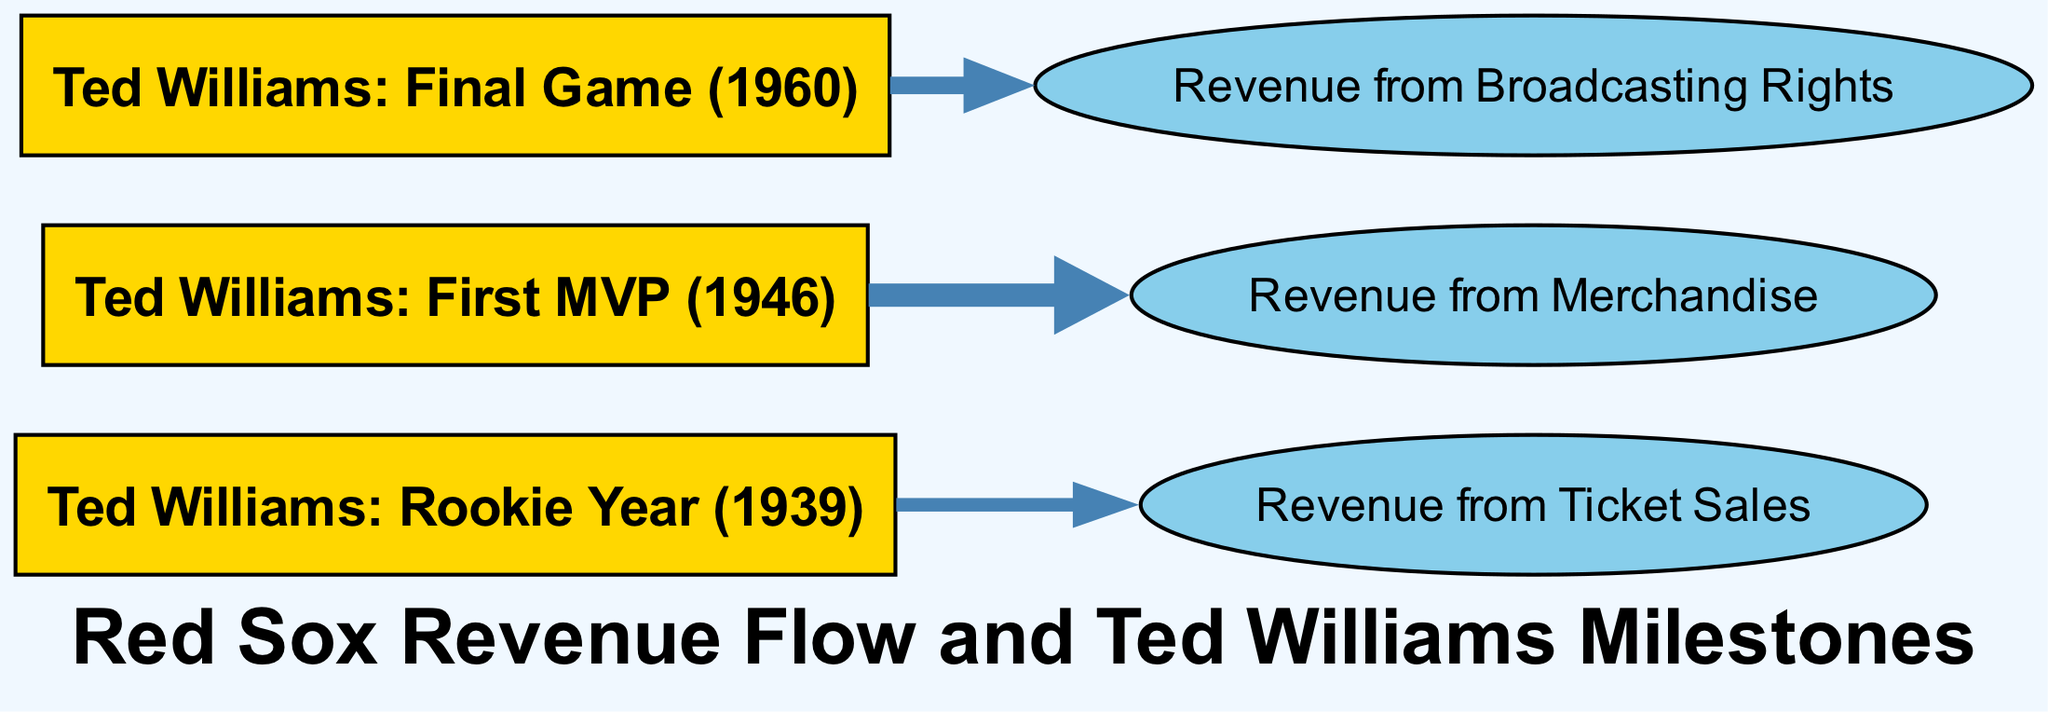What is the value associated with Ticket Sales from Ted Williams' rookie year? The diagram indicates a link from "Ted Williams: Rookie Year (1939)" to "Revenue from Ticket Sales" with a value of 5.
Answer: 5 What is the value associated with Merchandise from Ted Williams' first MVP year? According to the diagram, there is a link from "Ted Williams: First MVP (1946)" to "Revenue from Merchandise" with a value of 10.
Answer: 10 How many total revenue sources are depicted in the diagram? The diagram displays three revenue sources: Ticket Sales, Merchandise, and Broadcasting Rights, which totals to three distinct sources.
Answer: 3 Which milestone has the highest revenue flow? Comparing the values, the link from "Ted Williams: First MVP (1946)" to "Revenue from Merchandise" shows the highest value of 10, indicating it has the highest revenue flow.
Answer: Merchandise What is the relationship between Ted Williams' final game and Broadcasting Rights revenue? The diagram shows a link from "Ted Williams: Final Game (1960)" to "Broadcasting Rights" with a value of 7, indicating a direct relationship between this milestone and that source of revenue.
Answer: Direct relationship Which node has the least revenue value based on the diagram? The node "Ticket Sales" has a value of 5, while "Broadcasting Rights" (7) and "Merchandise" (10) have higher values, making Ticket Sales the least.
Answer: Ticket Sales How many links connect Ted Williams' milestones to revenue sources? There are three links connecting Ted Williams' milestones to revenue sources: one for each milestone (rookie year, first MVP, final game).
Answer: 3 What is the total revenue value flowing from Ted Williams' rookie year? The diagram shows that the revenue value flowing from Ted Williams' rookie year is solely to Ticket Sales, which is valued at 5.
Answer: 5 What color represents revenue nodes in the diagram? The revenue nodes, which include Ticket Sales, Merchandise, and Broadcasting Rights, are represented in a light blue color (#87CEEB).
Answer: Light blue 